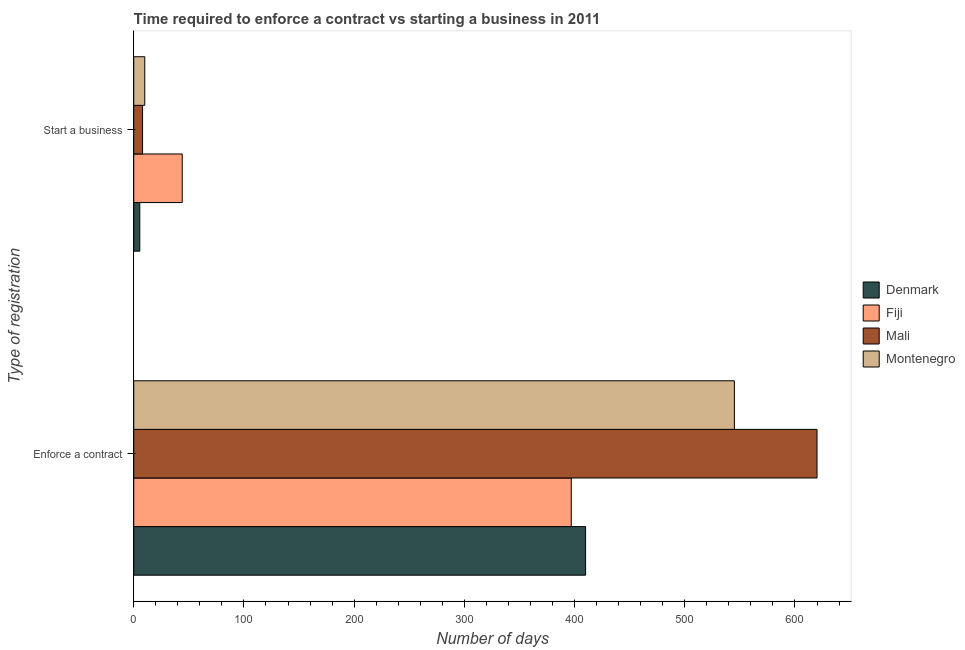Are the number of bars per tick equal to the number of legend labels?
Ensure brevity in your answer.  Yes. Are the number of bars on each tick of the Y-axis equal?
Your answer should be very brief. Yes. How many bars are there on the 1st tick from the top?
Your response must be concise. 4. How many bars are there on the 1st tick from the bottom?
Give a very brief answer. 4. What is the label of the 2nd group of bars from the top?
Give a very brief answer. Enforce a contract. What is the number of days to start a business in Denmark?
Your answer should be compact. 5.5. Across all countries, what is the maximum number of days to enforece a contract?
Offer a terse response. 620. Across all countries, what is the minimum number of days to enforece a contract?
Provide a succinct answer. 397. In which country was the number of days to start a business maximum?
Provide a succinct answer. Fiji. In which country was the number of days to enforece a contract minimum?
Offer a terse response. Fiji. What is the total number of days to enforece a contract in the graph?
Provide a short and direct response. 1972. What is the difference between the number of days to enforece a contract in Fiji and that in Montenegro?
Give a very brief answer. -148. What is the difference between the number of days to enforece a contract in Mali and the number of days to start a business in Denmark?
Your response must be concise. 614.5. What is the average number of days to start a business per country?
Ensure brevity in your answer.  16.88. What is the difference between the number of days to enforece a contract and number of days to start a business in Denmark?
Make the answer very short. 404.5. What is the ratio of the number of days to start a business in Montenegro to that in Mali?
Keep it short and to the point. 1.25. Is the number of days to enforece a contract in Denmark less than that in Montenegro?
Your response must be concise. Yes. What does the 1st bar from the top in Start a business represents?
Provide a short and direct response. Montenegro. What does the 3rd bar from the bottom in Enforce a contract represents?
Your answer should be compact. Mali. Are all the bars in the graph horizontal?
Provide a succinct answer. Yes. Are the values on the major ticks of X-axis written in scientific E-notation?
Provide a short and direct response. No. Does the graph contain any zero values?
Provide a short and direct response. No. Where does the legend appear in the graph?
Your answer should be compact. Center right. How many legend labels are there?
Give a very brief answer. 4. What is the title of the graph?
Your answer should be compact. Time required to enforce a contract vs starting a business in 2011. What is the label or title of the X-axis?
Your answer should be compact. Number of days. What is the label or title of the Y-axis?
Make the answer very short. Type of registration. What is the Number of days of Denmark in Enforce a contract?
Ensure brevity in your answer.  410. What is the Number of days of Fiji in Enforce a contract?
Offer a terse response. 397. What is the Number of days of Mali in Enforce a contract?
Provide a short and direct response. 620. What is the Number of days in Montenegro in Enforce a contract?
Your answer should be very brief. 545. What is the Number of days of Montenegro in Start a business?
Your answer should be compact. 10. Across all Type of registration, what is the maximum Number of days in Denmark?
Offer a very short reply. 410. Across all Type of registration, what is the maximum Number of days in Fiji?
Keep it short and to the point. 397. Across all Type of registration, what is the maximum Number of days of Mali?
Provide a succinct answer. 620. Across all Type of registration, what is the maximum Number of days in Montenegro?
Provide a short and direct response. 545. Across all Type of registration, what is the minimum Number of days in Fiji?
Your answer should be very brief. 44. Across all Type of registration, what is the minimum Number of days of Mali?
Your response must be concise. 8. What is the total Number of days in Denmark in the graph?
Give a very brief answer. 415.5. What is the total Number of days in Fiji in the graph?
Your answer should be very brief. 441. What is the total Number of days of Mali in the graph?
Your answer should be compact. 628. What is the total Number of days of Montenegro in the graph?
Offer a very short reply. 555. What is the difference between the Number of days in Denmark in Enforce a contract and that in Start a business?
Your answer should be compact. 404.5. What is the difference between the Number of days in Fiji in Enforce a contract and that in Start a business?
Offer a terse response. 353. What is the difference between the Number of days in Mali in Enforce a contract and that in Start a business?
Make the answer very short. 612. What is the difference between the Number of days in Montenegro in Enforce a contract and that in Start a business?
Your answer should be very brief. 535. What is the difference between the Number of days in Denmark in Enforce a contract and the Number of days in Fiji in Start a business?
Keep it short and to the point. 366. What is the difference between the Number of days in Denmark in Enforce a contract and the Number of days in Mali in Start a business?
Provide a short and direct response. 402. What is the difference between the Number of days in Fiji in Enforce a contract and the Number of days in Mali in Start a business?
Make the answer very short. 389. What is the difference between the Number of days of Fiji in Enforce a contract and the Number of days of Montenegro in Start a business?
Keep it short and to the point. 387. What is the difference between the Number of days of Mali in Enforce a contract and the Number of days of Montenegro in Start a business?
Your answer should be compact. 610. What is the average Number of days of Denmark per Type of registration?
Offer a terse response. 207.75. What is the average Number of days of Fiji per Type of registration?
Offer a very short reply. 220.5. What is the average Number of days in Mali per Type of registration?
Your answer should be compact. 314. What is the average Number of days in Montenegro per Type of registration?
Offer a terse response. 277.5. What is the difference between the Number of days in Denmark and Number of days in Fiji in Enforce a contract?
Your response must be concise. 13. What is the difference between the Number of days in Denmark and Number of days in Mali in Enforce a contract?
Keep it short and to the point. -210. What is the difference between the Number of days of Denmark and Number of days of Montenegro in Enforce a contract?
Ensure brevity in your answer.  -135. What is the difference between the Number of days of Fiji and Number of days of Mali in Enforce a contract?
Make the answer very short. -223. What is the difference between the Number of days in Fiji and Number of days in Montenegro in Enforce a contract?
Provide a short and direct response. -148. What is the difference between the Number of days in Mali and Number of days in Montenegro in Enforce a contract?
Give a very brief answer. 75. What is the difference between the Number of days of Denmark and Number of days of Fiji in Start a business?
Give a very brief answer. -38.5. What is the difference between the Number of days of Denmark and Number of days of Mali in Start a business?
Offer a terse response. -2.5. What is the difference between the Number of days of Denmark and Number of days of Montenegro in Start a business?
Ensure brevity in your answer.  -4.5. What is the difference between the Number of days of Fiji and Number of days of Montenegro in Start a business?
Your answer should be compact. 34. What is the ratio of the Number of days in Denmark in Enforce a contract to that in Start a business?
Your response must be concise. 74.55. What is the ratio of the Number of days in Fiji in Enforce a contract to that in Start a business?
Your answer should be very brief. 9.02. What is the ratio of the Number of days in Mali in Enforce a contract to that in Start a business?
Your answer should be compact. 77.5. What is the ratio of the Number of days of Montenegro in Enforce a contract to that in Start a business?
Provide a succinct answer. 54.5. What is the difference between the highest and the second highest Number of days of Denmark?
Make the answer very short. 404.5. What is the difference between the highest and the second highest Number of days in Fiji?
Provide a succinct answer. 353. What is the difference between the highest and the second highest Number of days of Mali?
Give a very brief answer. 612. What is the difference between the highest and the second highest Number of days in Montenegro?
Provide a succinct answer. 535. What is the difference between the highest and the lowest Number of days in Denmark?
Provide a succinct answer. 404.5. What is the difference between the highest and the lowest Number of days of Fiji?
Give a very brief answer. 353. What is the difference between the highest and the lowest Number of days of Mali?
Give a very brief answer. 612. What is the difference between the highest and the lowest Number of days of Montenegro?
Give a very brief answer. 535. 